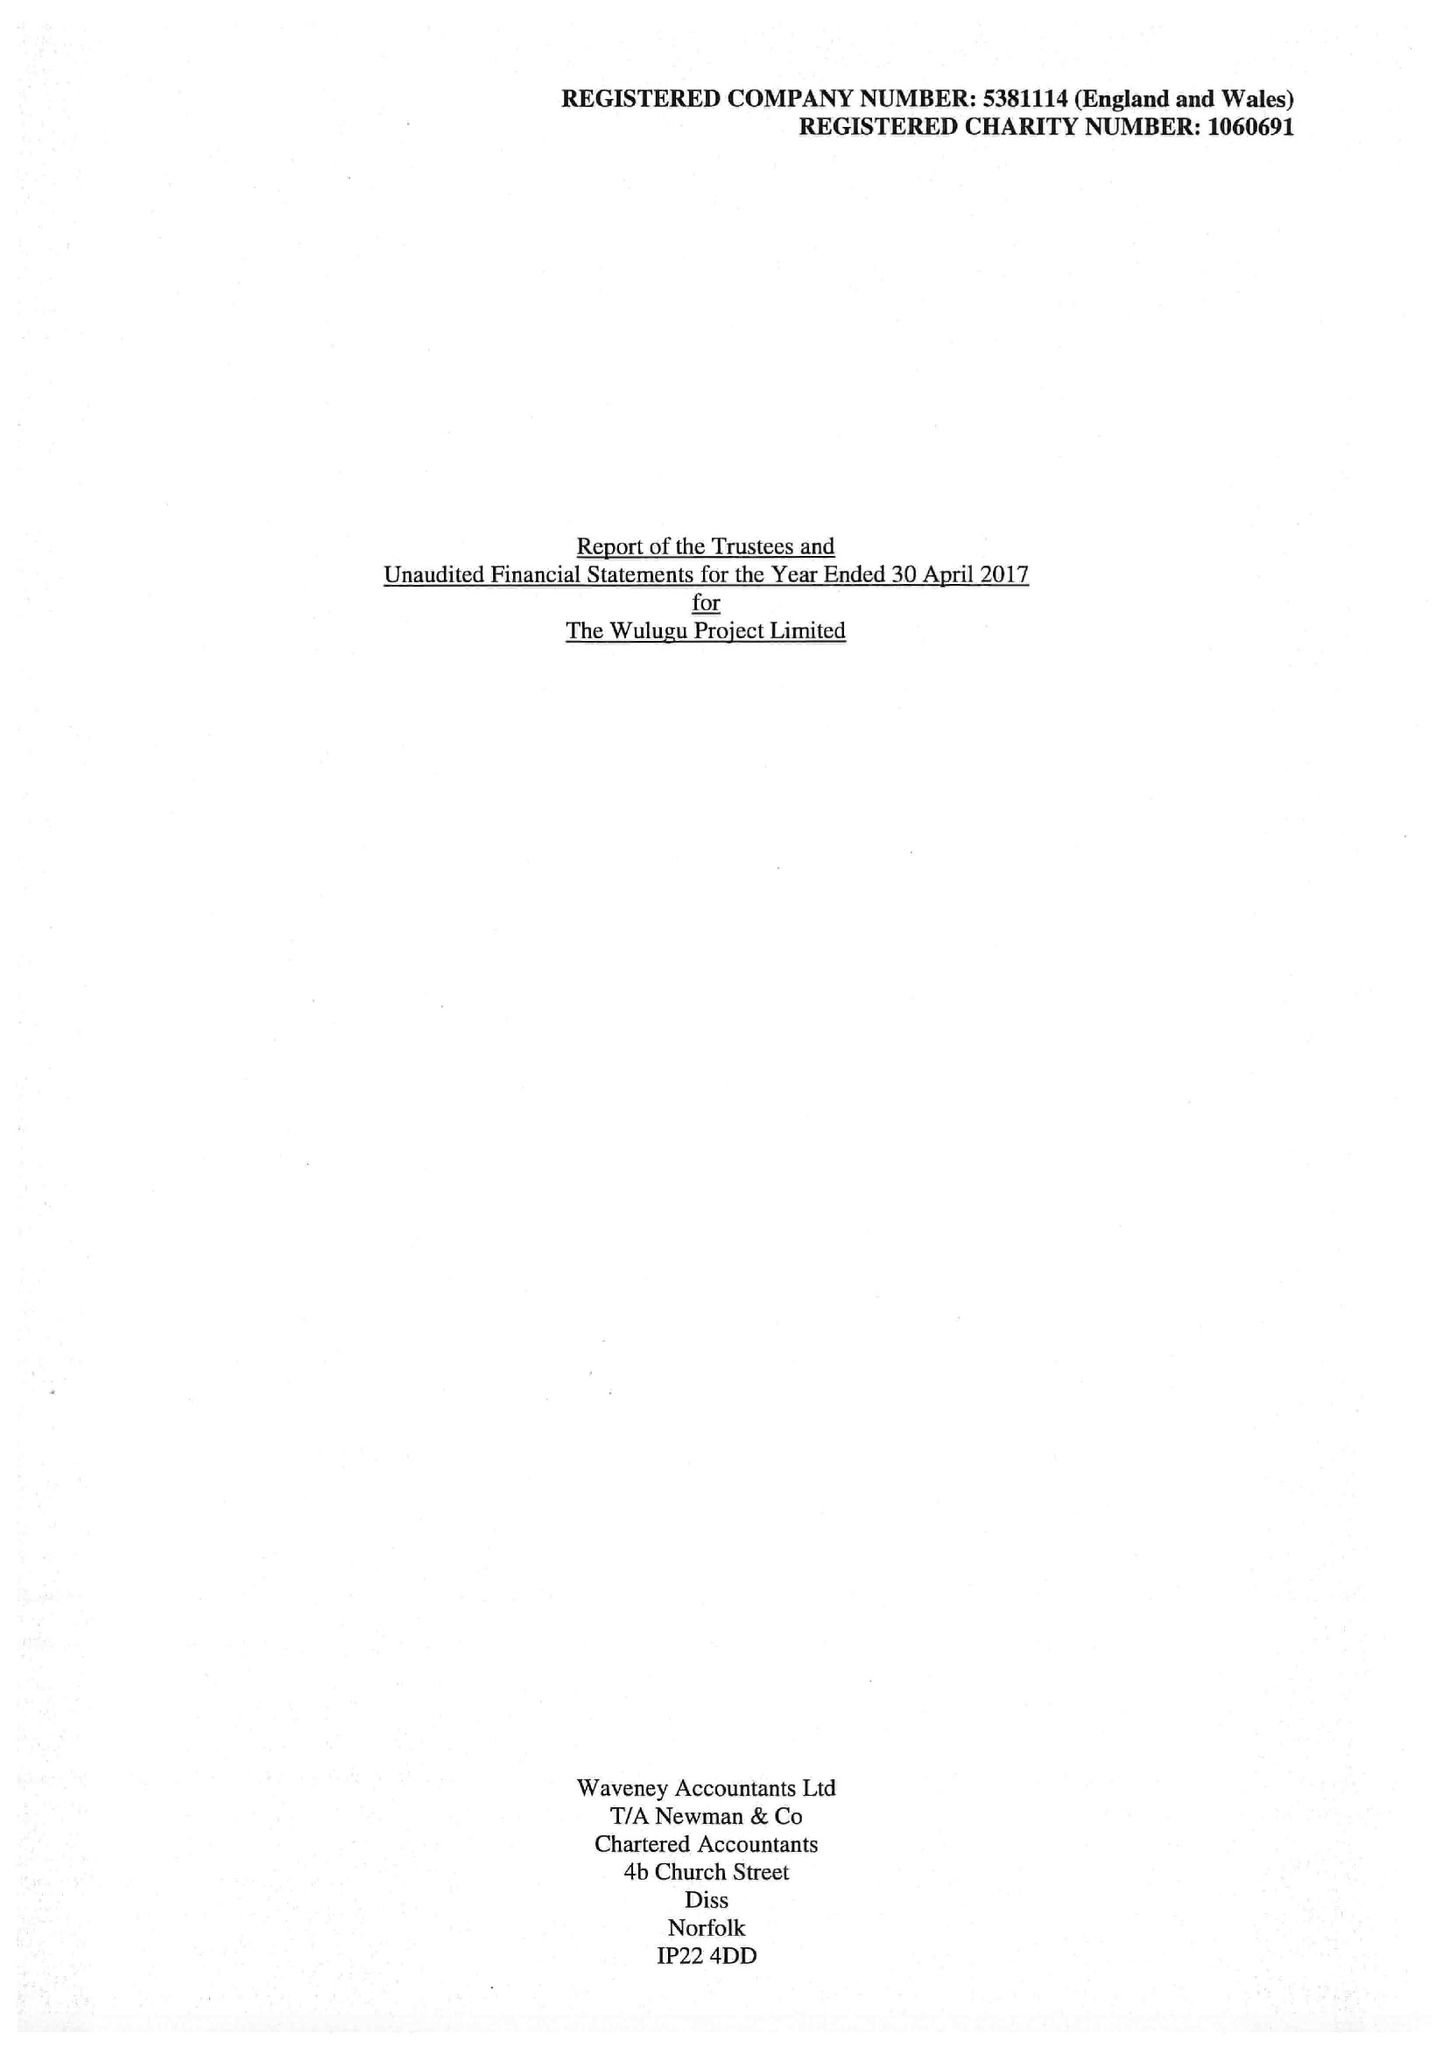What is the value for the spending_annually_in_british_pounds?
Answer the question using a single word or phrase. 102279.00 